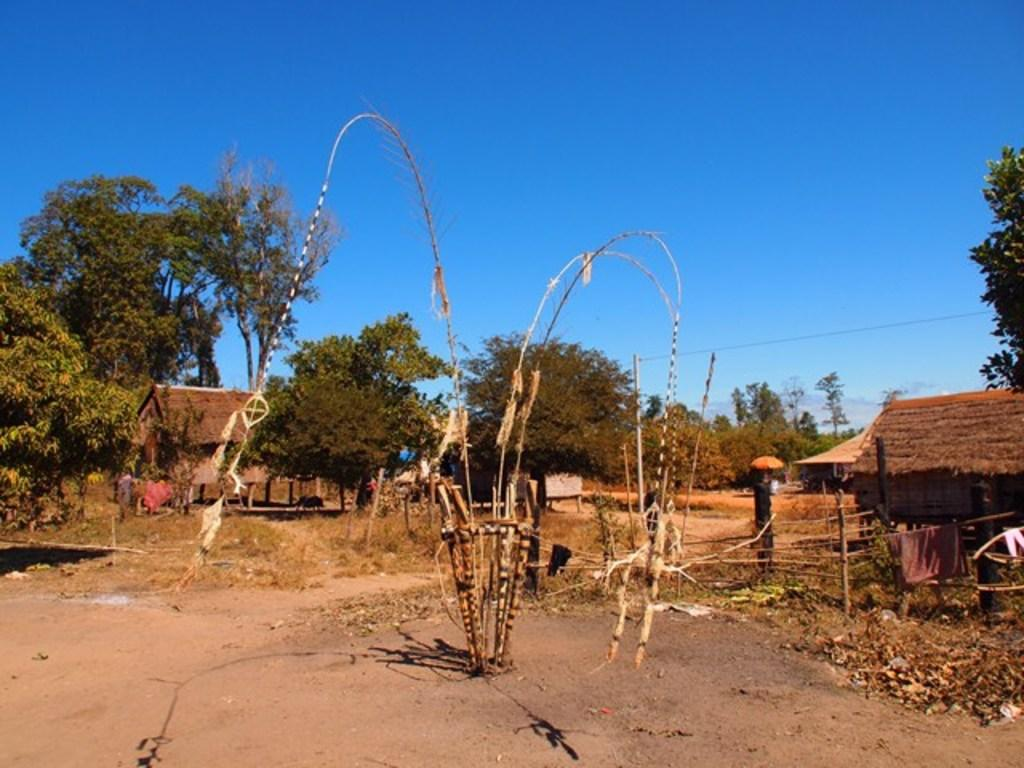What is the main subject in the middle of the image? There is a tree in the middle of the image. What can be seen at the bottom of the image? There is land at the bottom of the image. What structures are visible in the background of the image? There are houses in the background of the image. What type of vegetation can be seen in the background of the image? There are trees, plants, and grass in the background of the image. What living beings are present in the background of the image? There are people and an animal in the background of the image. What is visible in the sky in the background of the image? The sky is visible in the background of the image, with clouds present. What is the rate of the afterthought in the image? There is no mention of an afterthought or rate in the image. 